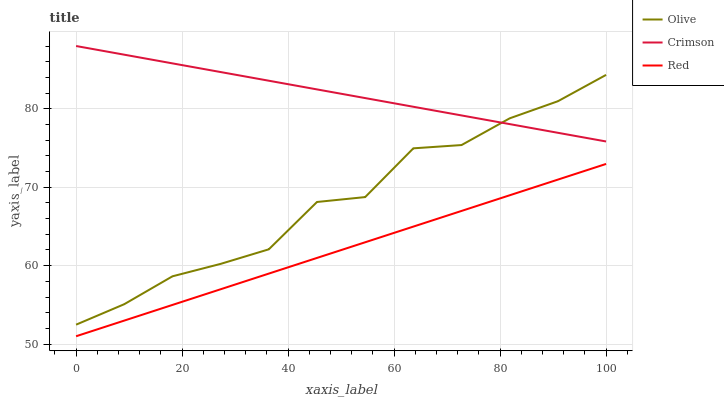Does Red have the minimum area under the curve?
Answer yes or no. Yes. Does Crimson have the maximum area under the curve?
Answer yes or no. Yes. Does Crimson have the minimum area under the curve?
Answer yes or no. No. Does Red have the maximum area under the curve?
Answer yes or no. No. Is Red the smoothest?
Answer yes or no. Yes. Is Olive the roughest?
Answer yes or no. Yes. Is Crimson the smoothest?
Answer yes or no. No. Is Crimson the roughest?
Answer yes or no. No. Does Crimson have the lowest value?
Answer yes or no. No. Does Red have the highest value?
Answer yes or no. No. Is Red less than Olive?
Answer yes or no. Yes. Is Crimson greater than Red?
Answer yes or no. Yes. Does Red intersect Olive?
Answer yes or no. No. 